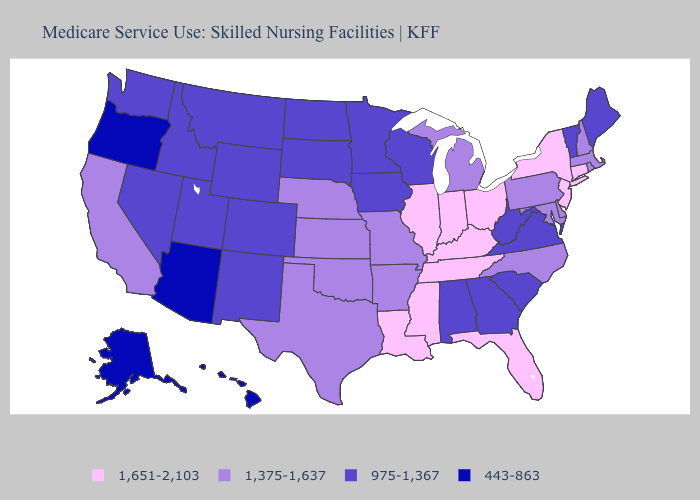What is the value of Oklahoma?
Keep it brief. 1,375-1,637. Name the states that have a value in the range 443-863?
Give a very brief answer. Alaska, Arizona, Hawaii, Oregon. Does Utah have the highest value in the West?
Short answer required. No. What is the value of Rhode Island?
Be succinct. 1,375-1,637. Name the states that have a value in the range 443-863?
Quick response, please. Alaska, Arizona, Hawaii, Oregon. Does Colorado have the lowest value in the West?
Write a very short answer. No. What is the value of Maryland?
Keep it brief. 1,375-1,637. What is the highest value in the South ?
Concise answer only. 1,651-2,103. What is the value of Florida?
Concise answer only. 1,651-2,103. Does Hawaii have the lowest value in the USA?
Short answer required. Yes. What is the lowest value in states that border Iowa?
Concise answer only. 975-1,367. Does Massachusetts have the lowest value in the Northeast?
Keep it brief. No. Which states have the lowest value in the USA?
Keep it brief. Alaska, Arizona, Hawaii, Oregon. Among the states that border South Dakota , which have the highest value?
Be succinct. Nebraska. Which states have the highest value in the USA?
Quick response, please. Connecticut, Florida, Illinois, Indiana, Kentucky, Louisiana, Mississippi, New Jersey, New York, Ohio, Tennessee. 